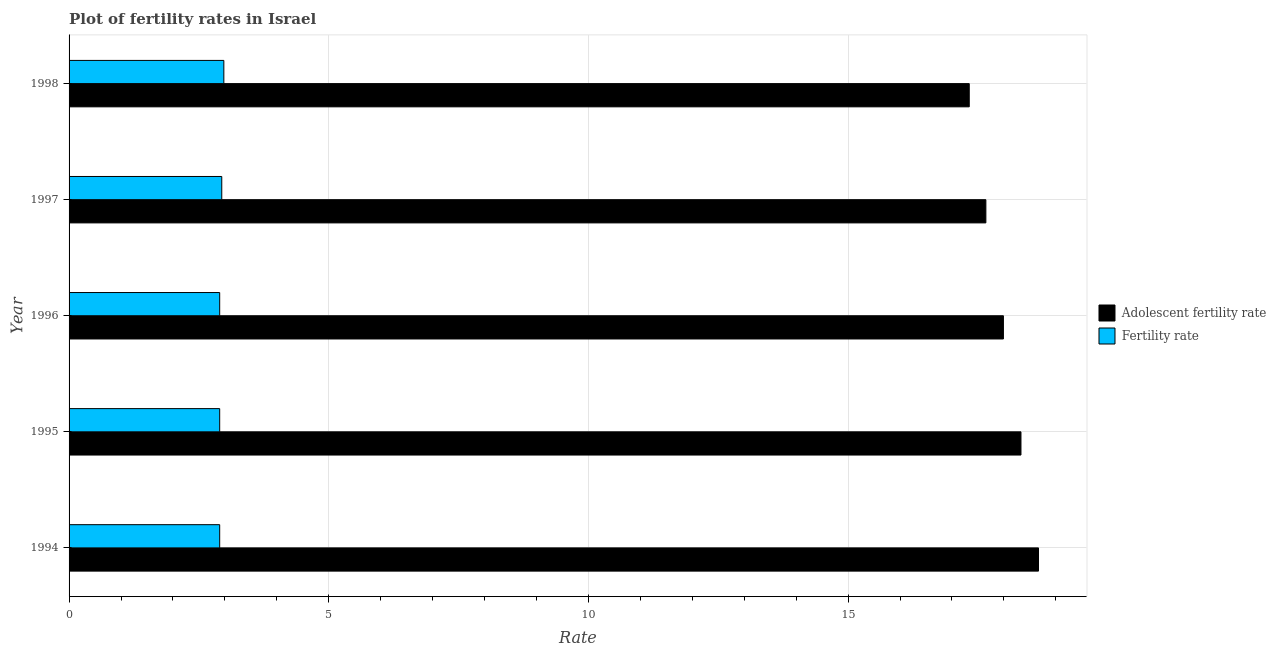How many different coloured bars are there?
Provide a succinct answer. 2. Are the number of bars on each tick of the Y-axis equal?
Provide a short and direct response. Yes. In how many cases, is the number of bars for a given year not equal to the number of legend labels?
Ensure brevity in your answer.  0. What is the fertility rate in 1995?
Keep it short and to the point. 2.9. Across all years, what is the maximum adolescent fertility rate?
Your answer should be very brief. 18.67. What is the total fertility rate in the graph?
Offer a terse response. 14.62. What is the difference between the fertility rate in 1994 and that in 1998?
Keep it short and to the point. -0.08. What is the difference between the adolescent fertility rate in 1994 and the fertility rate in 1997?
Keep it short and to the point. 15.73. What is the average adolescent fertility rate per year?
Keep it short and to the point. 17.99. In the year 1997, what is the difference between the fertility rate and adolescent fertility rate?
Make the answer very short. -14.71. In how many years, is the fertility rate greater than 11 ?
Your response must be concise. 0. Is the fertility rate in 1995 less than that in 1996?
Give a very brief answer. No. What is the difference between the highest and the lowest adolescent fertility rate?
Your response must be concise. 1.33. Is the sum of the adolescent fertility rate in 1995 and 1996 greater than the maximum fertility rate across all years?
Your response must be concise. Yes. What does the 1st bar from the top in 1997 represents?
Keep it short and to the point. Fertility rate. What does the 1st bar from the bottom in 1996 represents?
Offer a very short reply. Adolescent fertility rate. Are all the bars in the graph horizontal?
Provide a succinct answer. Yes. What is the difference between two consecutive major ticks on the X-axis?
Your answer should be very brief. 5. Does the graph contain any zero values?
Offer a terse response. No. Where does the legend appear in the graph?
Provide a short and direct response. Center right. How many legend labels are there?
Provide a short and direct response. 2. What is the title of the graph?
Your answer should be compact. Plot of fertility rates in Israel. What is the label or title of the X-axis?
Your response must be concise. Rate. What is the label or title of the Y-axis?
Your answer should be compact. Year. What is the Rate in Adolescent fertility rate in 1994?
Provide a short and direct response. 18.67. What is the Rate in Adolescent fertility rate in 1995?
Keep it short and to the point. 18.33. What is the Rate in Adolescent fertility rate in 1996?
Give a very brief answer. 17.99. What is the Rate in Fertility rate in 1996?
Provide a succinct answer. 2.9. What is the Rate of Adolescent fertility rate in 1997?
Offer a terse response. 17.65. What is the Rate in Fertility rate in 1997?
Keep it short and to the point. 2.94. What is the Rate of Adolescent fertility rate in 1998?
Your answer should be compact. 17.33. What is the Rate of Fertility rate in 1998?
Your response must be concise. 2.98. Across all years, what is the maximum Rate of Adolescent fertility rate?
Keep it short and to the point. 18.67. Across all years, what is the maximum Rate of Fertility rate?
Offer a very short reply. 2.98. Across all years, what is the minimum Rate in Adolescent fertility rate?
Your answer should be compact. 17.33. What is the total Rate in Adolescent fertility rate in the graph?
Your answer should be very brief. 89.97. What is the total Rate of Fertility rate in the graph?
Offer a terse response. 14.62. What is the difference between the Rate in Adolescent fertility rate in 1994 and that in 1995?
Keep it short and to the point. 0.34. What is the difference between the Rate in Fertility rate in 1994 and that in 1995?
Keep it short and to the point. 0. What is the difference between the Rate in Adolescent fertility rate in 1994 and that in 1996?
Your answer should be very brief. 0.68. What is the difference between the Rate of Fertility rate in 1994 and that in 1996?
Offer a terse response. 0. What is the difference between the Rate of Adolescent fertility rate in 1994 and that in 1997?
Your answer should be compact. 1.01. What is the difference between the Rate of Fertility rate in 1994 and that in 1997?
Offer a terse response. -0.04. What is the difference between the Rate of Adolescent fertility rate in 1994 and that in 1998?
Offer a very short reply. 1.33. What is the difference between the Rate in Fertility rate in 1994 and that in 1998?
Make the answer very short. -0.08. What is the difference between the Rate in Adolescent fertility rate in 1995 and that in 1996?
Offer a terse response. 0.34. What is the difference between the Rate in Fertility rate in 1995 and that in 1996?
Provide a short and direct response. 0. What is the difference between the Rate of Adolescent fertility rate in 1995 and that in 1997?
Offer a very short reply. 0.68. What is the difference between the Rate in Fertility rate in 1995 and that in 1997?
Your answer should be very brief. -0.04. What is the difference between the Rate in Adolescent fertility rate in 1995 and that in 1998?
Your answer should be compact. 1. What is the difference between the Rate of Fertility rate in 1995 and that in 1998?
Offer a very short reply. -0.08. What is the difference between the Rate in Adolescent fertility rate in 1996 and that in 1997?
Your response must be concise. 0.34. What is the difference between the Rate in Fertility rate in 1996 and that in 1997?
Make the answer very short. -0.04. What is the difference between the Rate of Adolescent fertility rate in 1996 and that in 1998?
Offer a very short reply. 0.66. What is the difference between the Rate of Fertility rate in 1996 and that in 1998?
Your answer should be very brief. -0.08. What is the difference between the Rate in Adolescent fertility rate in 1997 and that in 1998?
Provide a short and direct response. 0.32. What is the difference between the Rate of Fertility rate in 1997 and that in 1998?
Make the answer very short. -0.04. What is the difference between the Rate of Adolescent fertility rate in 1994 and the Rate of Fertility rate in 1995?
Make the answer very short. 15.77. What is the difference between the Rate of Adolescent fertility rate in 1994 and the Rate of Fertility rate in 1996?
Offer a terse response. 15.77. What is the difference between the Rate in Adolescent fertility rate in 1994 and the Rate in Fertility rate in 1997?
Your response must be concise. 15.73. What is the difference between the Rate in Adolescent fertility rate in 1994 and the Rate in Fertility rate in 1998?
Your response must be concise. 15.69. What is the difference between the Rate in Adolescent fertility rate in 1995 and the Rate in Fertility rate in 1996?
Give a very brief answer. 15.43. What is the difference between the Rate in Adolescent fertility rate in 1995 and the Rate in Fertility rate in 1997?
Your response must be concise. 15.39. What is the difference between the Rate of Adolescent fertility rate in 1995 and the Rate of Fertility rate in 1998?
Keep it short and to the point. 15.35. What is the difference between the Rate in Adolescent fertility rate in 1996 and the Rate in Fertility rate in 1997?
Your response must be concise. 15.05. What is the difference between the Rate of Adolescent fertility rate in 1996 and the Rate of Fertility rate in 1998?
Offer a terse response. 15.01. What is the difference between the Rate of Adolescent fertility rate in 1997 and the Rate of Fertility rate in 1998?
Your response must be concise. 14.67. What is the average Rate in Adolescent fertility rate per year?
Your answer should be compact. 17.99. What is the average Rate in Fertility rate per year?
Your answer should be compact. 2.92. In the year 1994, what is the difference between the Rate in Adolescent fertility rate and Rate in Fertility rate?
Provide a succinct answer. 15.77. In the year 1995, what is the difference between the Rate of Adolescent fertility rate and Rate of Fertility rate?
Your response must be concise. 15.43. In the year 1996, what is the difference between the Rate of Adolescent fertility rate and Rate of Fertility rate?
Give a very brief answer. 15.09. In the year 1997, what is the difference between the Rate in Adolescent fertility rate and Rate in Fertility rate?
Your response must be concise. 14.71. In the year 1998, what is the difference between the Rate in Adolescent fertility rate and Rate in Fertility rate?
Give a very brief answer. 14.35. What is the ratio of the Rate in Adolescent fertility rate in 1994 to that in 1995?
Give a very brief answer. 1.02. What is the ratio of the Rate of Fertility rate in 1994 to that in 1995?
Your answer should be compact. 1. What is the ratio of the Rate in Adolescent fertility rate in 1994 to that in 1996?
Ensure brevity in your answer.  1.04. What is the ratio of the Rate of Adolescent fertility rate in 1994 to that in 1997?
Keep it short and to the point. 1.06. What is the ratio of the Rate of Fertility rate in 1994 to that in 1997?
Offer a very short reply. 0.99. What is the ratio of the Rate of Adolescent fertility rate in 1994 to that in 1998?
Offer a terse response. 1.08. What is the ratio of the Rate of Fertility rate in 1994 to that in 1998?
Offer a very short reply. 0.97. What is the ratio of the Rate of Adolescent fertility rate in 1995 to that in 1996?
Your response must be concise. 1.02. What is the ratio of the Rate of Fertility rate in 1995 to that in 1996?
Provide a succinct answer. 1. What is the ratio of the Rate of Adolescent fertility rate in 1995 to that in 1997?
Provide a succinct answer. 1.04. What is the ratio of the Rate in Fertility rate in 1995 to that in 1997?
Provide a succinct answer. 0.99. What is the ratio of the Rate in Adolescent fertility rate in 1995 to that in 1998?
Offer a very short reply. 1.06. What is the ratio of the Rate in Fertility rate in 1995 to that in 1998?
Offer a terse response. 0.97. What is the ratio of the Rate in Adolescent fertility rate in 1996 to that in 1997?
Give a very brief answer. 1.02. What is the ratio of the Rate in Fertility rate in 1996 to that in 1997?
Provide a short and direct response. 0.99. What is the ratio of the Rate in Adolescent fertility rate in 1996 to that in 1998?
Offer a terse response. 1.04. What is the ratio of the Rate in Fertility rate in 1996 to that in 1998?
Provide a short and direct response. 0.97. What is the ratio of the Rate of Adolescent fertility rate in 1997 to that in 1998?
Your answer should be compact. 1.02. What is the ratio of the Rate in Fertility rate in 1997 to that in 1998?
Your answer should be very brief. 0.99. What is the difference between the highest and the second highest Rate of Adolescent fertility rate?
Provide a short and direct response. 0.34. What is the difference between the highest and the second highest Rate in Fertility rate?
Make the answer very short. 0.04. What is the difference between the highest and the lowest Rate in Adolescent fertility rate?
Offer a very short reply. 1.33. What is the difference between the highest and the lowest Rate in Fertility rate?
Ensure brevity in your answer.  0.08. 